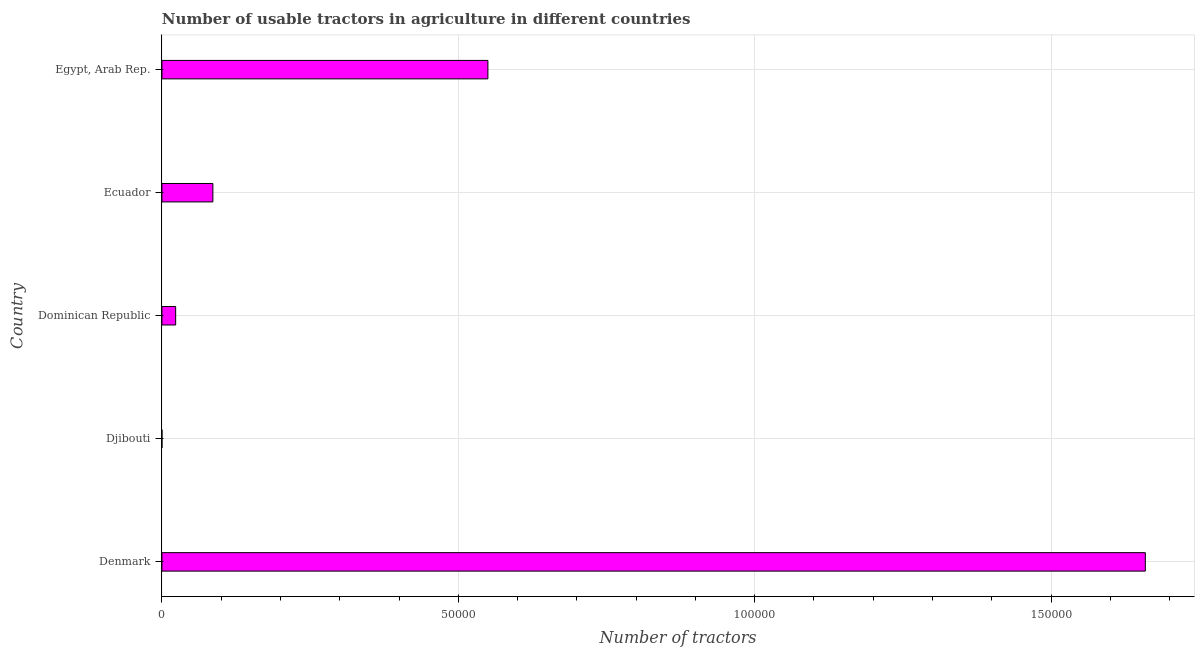Does the graph contain any zero values?
Ensure brevity in your answer.  No. What is the title of the graph?
Your response must be concise. Number of usable tractors in agriculture in different countries. What is the label or title of the X-axis?
Your answer should be very brief. Number of tractors. What is the label or title of the Y-axis?
Your answer should be very brief. Country. What is the number of tractors in Dominican Republic?
Offer a terse response. 2320. Across all countries, what is the maximum number of tractors?
Ensure brevity in your answer.  1.66e+05. In which country was the number of tractors maximum?
Offer a terse response. Denmark. In which country was the number of tractors minimum?
Your response must be concise. Djibouti. What is the sum of the number of tractors?
Ensure brevity in your answer.  2.32e+05. What is the difference between the number of tractors in Djibouti and Dominican Republic?
Give a very brief answer. -2312. What is the average number of tractors per country?
Your response must be concise. 4.64e+04. What is the median number of tractors?
Keep it short and to the point. 8600. In how many countries, is the number of tractors greater than 150000 ?
Provide a short and direct response. 1. What is the ratio of the number of tractors in Dominican Republic to that in Ecuador?
Your answer should be very brief. 0.27. What is the difference between the highest and the second highest number of tractors?
Make the answer very short. 1.11e+05. What is the difference between the highest and the lowest number of tractors?
Ensure brevity in your answer.  1.66e+05. How many bars are there?
Offer a terse response. 5. Are all the bars in the graph horizontal?
Your response must be concise. Yes. How many countries are there in the graph?
Your answer should be compact. 5. What is the Number of tractors of Denmark?
Provide a short and direct response. 1.66e+05. What is the Number of tractors in Dominican Republic?
Give a very brief answer. 2320. What is the Number of tractors in Ecuador?
Your answer should be very brief. 8600. What is the Number of tractors in Egypt, Arab Rep.?
Offer a terse response. 5.50e+04. What is the difference between the Number of tractors in Denmark and Djibouti?
Keep it short and to the point. 1.66e+05. What is the difference between the Number of tractors in Denmark and Dominican Republic?
Your answer should be very brief. 1.64e+05. What is the difference between the Number of tractors in Denmark and Ecuador?
Keep it short and to the point. 1.57e+05. What is the difference between the Number of tractors in Denmark and Egypt, Arab Rep.?
Provide a succinct answer. 1.11e+05. What is the difference between the Number of tractors in Djibouti and Dominican Republic?
Offer a very short reply. -2312. What is the difference between the Number of tractors in Djibouti and Ecuador?
Make the answer very short. -8592. What is the difference between the Number of tractors in Djibouti and Egypt, Arab Rep.?
Offer a very short reply. -5.50e+04. What is the difference between the Number of tractors in Dominican Republic and Ecuador?
Your answer should be compact. -6280. What is the difference between the Number of tractors in Dominican Republic and Egypt, Arab Rep.?
Your answer should be compact. -5.27e+04. What is the difference between the Number of tractors in Ecuador and Egypt, Arab Rep.?
Offer a terse response. -4.64e+04. What is the ratio of the Number of tractors in Denmark to that in Djibouti?
Your answer should be very brief. 2.07e+04. What is the ratio of the Number of tractors in Denmark to that in Dominican Republic?
Keep it short and to the point. 71.51. What is the ratio of the Number of tractors in Denmark to that in Ecuador?
Your answer should be very brief. 19.29. What is the ratio of the Number of tractors in Denmark to that in Egypt, Arab Rep.?
Provide a short and direct response. 3.02. What is the ratio of the Number of tractors in Djibouti to that in Dominican Republic?
Make the answer very short. 0. What is the ratio of the Number of tractors in Djibouti to that in Ecuador?
Offer a very short reply. 0. What is the ratio of the Number of tractors in Dominican Republic to that in Ecuador?
Provide a short and direct response. 0.27. What is the ratio of the Number of tractors in Dominican Republic to that in Egypt, Arab Rep.?
Your answer should be compact. 0.04. What is the ratio of the Number of tractors in Ecuador to that in Egypt, Arab Rep.?
Your answer should be very brief. 0.16. 